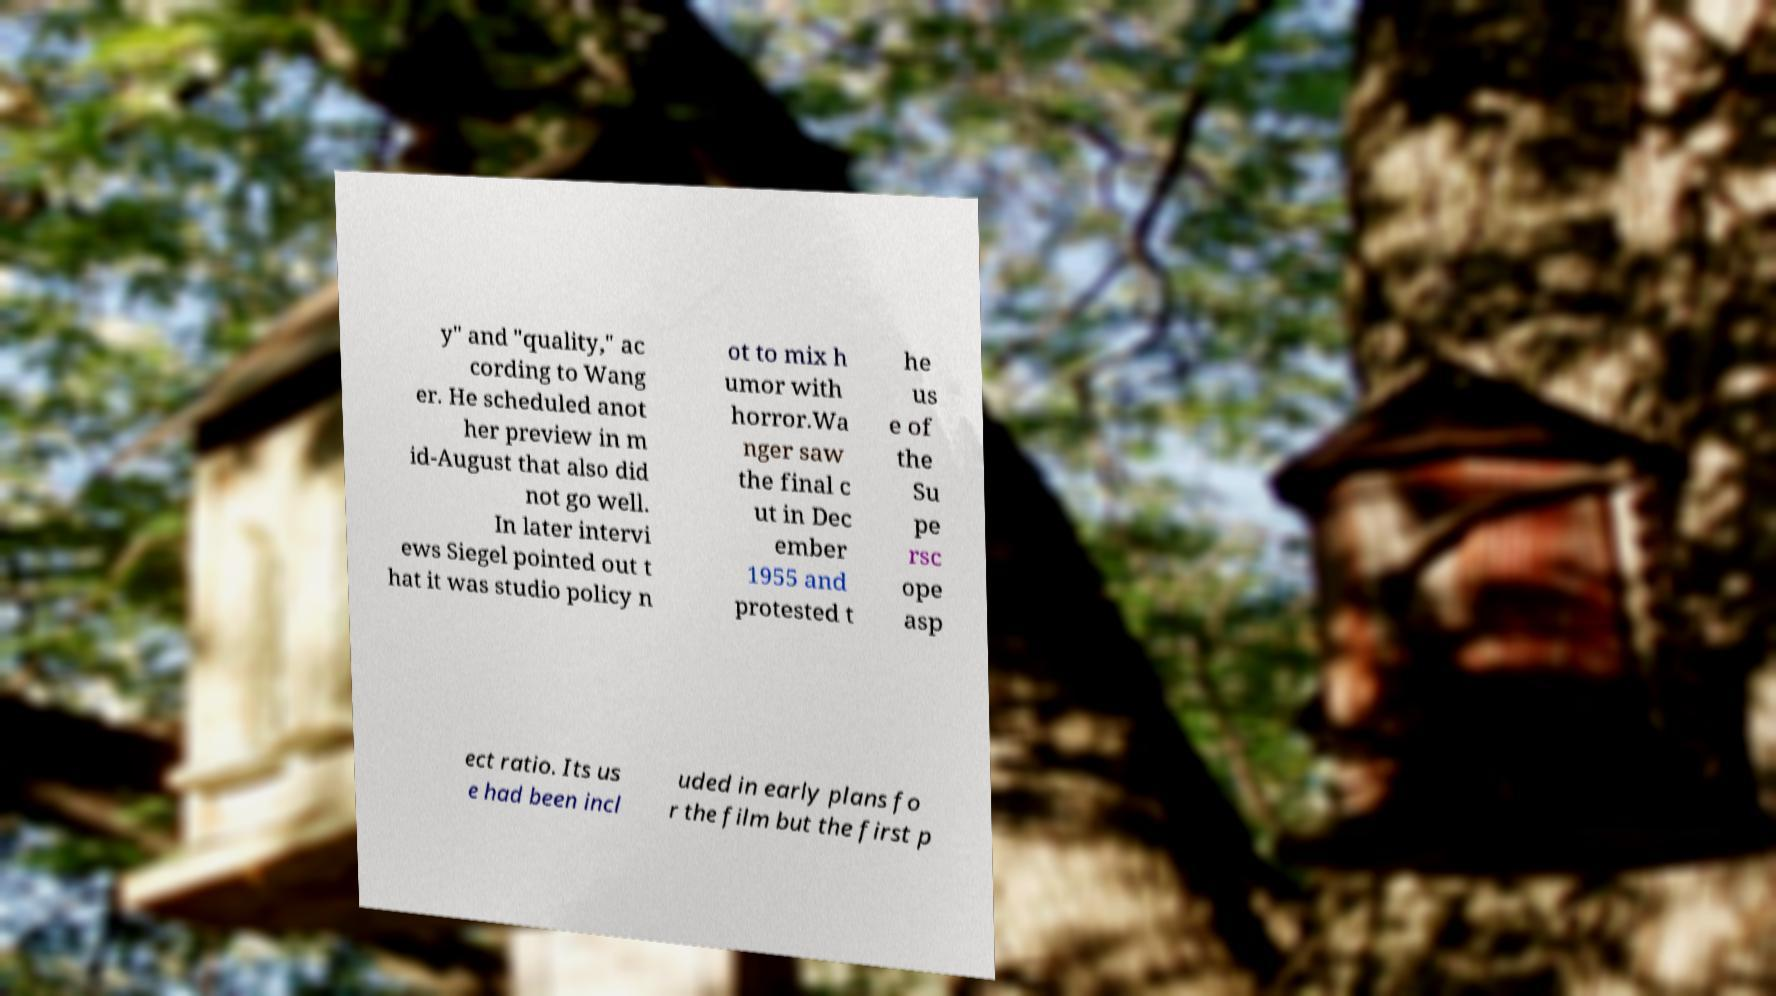Could you assist in decoding the text presented in this image and type it out clearly? y" and "quality," ac cording to Wang er. He scheduled anot her preview in m id-August that also did not go well. In later intervi ews Siegel pointed out t hat it was studio policy n ot to mix h umor with horror.Wa nger saw the final c ut in Dec ember 1955 and protested t he us e of the Su pe rsc ope asp ect ratio. Its us e had been incl uded in early plans fo r the film but the first p 